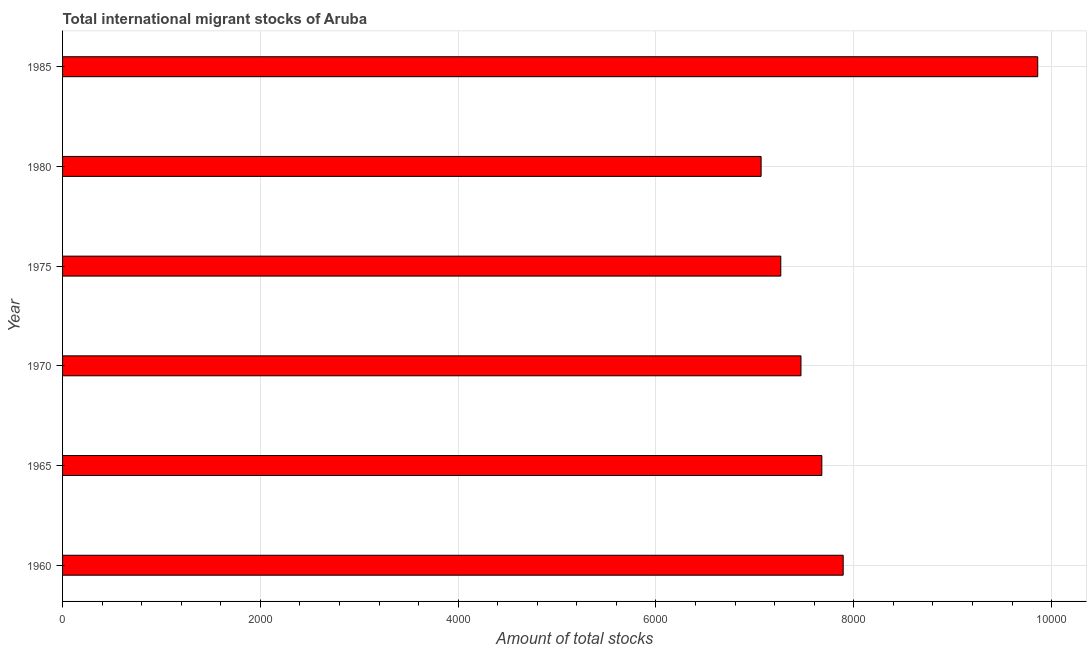What is the title of the graph?
Keep it short and to the point. Total international migrant stocks of Aruba. What is the label or title of the X-axis?
Offer a terse response. Amount of total stocks. What is the label or title of the Y-axis?
Your answer should be very brief. Year. What is the total number of international migrant stock in 1980?
Give a very brief answer. 7063. Across all years, what is the maximum total number of international migrant stock?
Your response must be concise. 9860. Across all years, what is the minimum total number of international migrant stock?
Keep it short and to the point. 7063. In which year was the total number of international migrant stock minimum?
Keep it short and to the point. 1980. What is the sum of the total number of international migrant stock?
Give a very brief answer. 4.72e+04. What is the difference between the total number of international migrant stock in 1970 and 1975?
Provide a succinct answer. 204. What is the average total number of international migrant stock per year?
Provide a short and direct response. 7870. What is the median total number of international migrant stock?
Offer a very short reply. 7571.5. Do a majority of the years between 1965 and 1960 (inclusive) have total number of international migrant stock greater than 3200 ?
Your answer should be compact. No. What is the ratio of the total number of international migrant stock in 1970 to that in 1985?
Your response must be concise. 0.76. Is the total number of international migrant stock in 1970 less than that in 1985?
Provide a succinct answer. Yes. Is the difference between the total number of international migrant stock in 1960 and 1975 greater than the difference between any two years?
Provide a succinct answer. No. What is the difference between the highest and the second highest total number of international migrant stock?
Keep it short and to the point. 1967. Is the sum of the total number of international migrant stock in 1975 and 1985 greater than the maximum total number of international migrant stock across all years?
Provide a short and direct response. Yes. What is the difference between the highest and the lowest total number of international migrant stock?
Provide a short and direct response. 2797. How many bars are there?
Provide a succinct answer. 6. How many years are there in the graph?
Give a very brief answer. 6. What is the difference between two consecutive major ticks on the X-axis?
Your response must be concise. 2000. Are the values on the major ticks of X-axis written in scientific E-notation?
Offer a terse response. No. What is the Amount of total stocks of 1960?
Your response must be concise. 7893. What is the Amount of total stocks of 1965?
Your answer should be compact. 7677. What is the Amount of total stocks in 1970?
Your response must be concise. 7466. What is the Amount of total stocks of 1975?
Give a very brief answer. 7262. What is the Amount of total stocks in 1980?
Provide a succinct answer. 7063. What is the Amount of total stocks in 1985?
Make the answer very short. 9860. What is the difference between the Amount of total stocks in 1960 and 1965?
Your answer should be very brief. 216. What is the difference between the Amount of total stocks in 1960 and 1970?
Your response must be concise. 427. What is the difference between the Amount of total stocks in 1960 and 1975?
Your answer should be very brief. 631. What is the difference between the Amount of total stocks in 1960 and 1980?
Offer a terse response. 830. What is the difference between the Amount of total stocks in 1960 and 1985?
Your answer should be compact. -1967. What is the difference between the Amount of total stocks in 1965 and 1970?
Provide a short and direct response. 211. What is the difference between the Amount of total stocks in 1965 and 1975?
Provide a succinct answer. 415. What is the difference between the Amount of total stocks in 1965 and 1980?
Offer a terse response. 614. What is the difference between the Amount of total stocks in 1965 and 1985?
Ensure brevity in your answer.  -2183. What is the difference between the Amount of total stocks in 1970 and 1975?
Make the answer very short. 204. What is the difference between the Amount of total stocks in 1970 and 1980?
Your response must be concise. 403. What is the difference between the Amount of total stocks in 1970 and 1985?
Provide a short and direct response. -2394. What is the difference between the Amount of total stocks in 1975 and 1980?
Provide a short and direct response. 199. What is the difference between the Amount of total stocks in 1975 and 1985?
Your response must be concise. -2598. What is the difference between the Amount of total stocks in 1980 and 1985?
Make the answer very short. -2797. What is the ratio of the Amount of total stocks in 1960 to that in 1965?
Make the answer very short. 1.03. What is the ratio of the Amount of total stocks in 1960 to that in 1970?
Your response must be concise. 1.06. What is the ratio of the Amount of total stocks in 1960 to that in 1975?
Keep it short and to the point. 1.09. What is the ratio of the Amount of total stocks in 1960 to that in 1980?
Give a very brief answer. 1.12. What is the ratio of the Amount of total stocks in 1960 to that in 1985?
Provide a succinct answer. 0.8. What is the ratio of the Amount of total stocks in 1965 to that in 1970?
Ensure brevity in your answer.  1.03. What is the ratio of the Amount of total stocks in 1965 to that in 1975?
Keep it short and to the point. 1.06. What is the ratio of the Amount of total stocks in 1965 to that in 1980?
Your answer should be very brief. 1.09. What is the ratio of the Amount of total stocks in 1965 to that in 1985?
Provide a succinct answer. 0.78. What is the ratio of the Amount of total stocks in 1970 to that in 1975?
Give a very brief answer. 1.03. What is the ratio of the Amount of total stocks in 1970 to that in 1980?
Provide a succinct answer. 1.06. What is the ratio of the Amount of total stocks in 1970 to that in 1985?
Your answer should be very brief. 0.76. What is the ratio of the Amount of total stocks in 1975 to that in 1980?
Provide a succinct answer. 1.03. What is the ratio of the Amount of total stocks in 1975 to that in 1985?
Offer a very short reply. 0.74. What is the ratio of the Amount of total stocks in 1980 to that in 1985?
Ensure brevity in your answer.  0.72. 